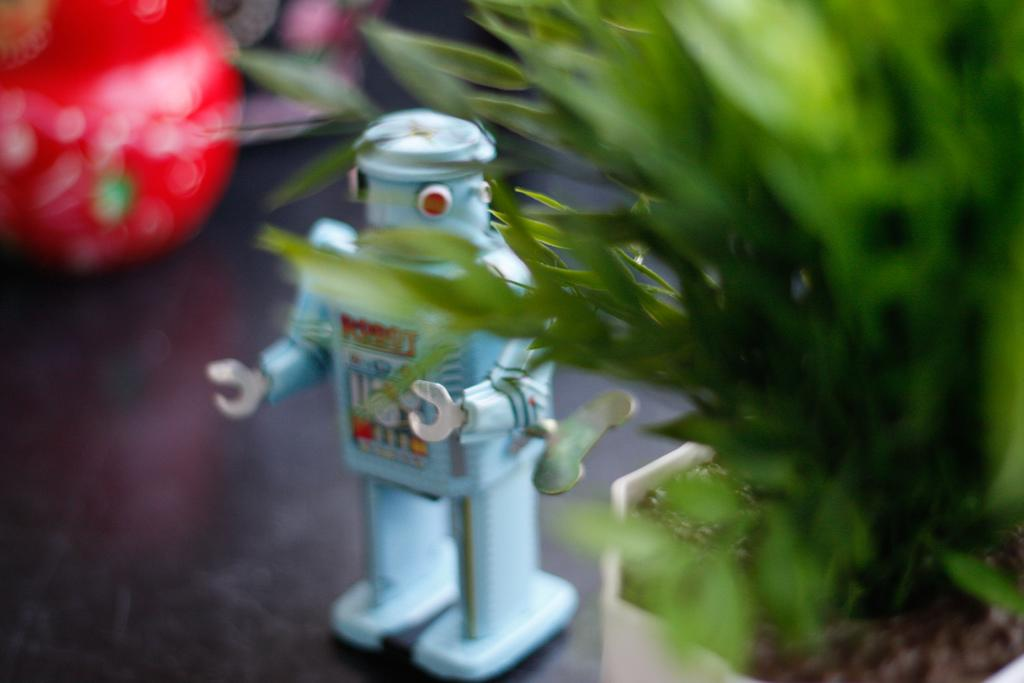What color is the toy on the floor in the image? The toy on the floor is gray in color. What can be seen on the right side of the image? There is a pot plant on the right side of the image. Can you describe the background of the image? The background of the image is blurred. What type of straw is being used to build a house in the image? There is no straw or house present in the image; it only features a gray toy on the floor and a pot plant on the right side. 